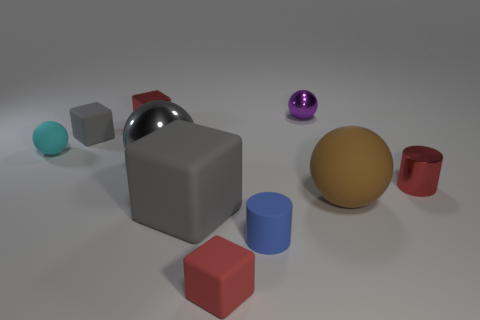There is a gray block on the left side of the gray thing that is in front of the brown matte ball; are there any large gray metallic balls right of it?
Keep it short and to the point. Yes. What material is the gray sphere that is in front of the shiny cube?
Provide a short and direct response. Metal. There is a tiny gray object; is it the same shape as the small purple metallic thing to the left of the tiny metallic cylinder?
Your response must be concise. No. Are there an equal number of red matte blocks that are behind the large gray rubber cube and large gray objects behind the purple metallic thing?
Make the answer very short. Yes. How many other things are made of the same material as the tiny cyan sphere?
Provide a short and direct response. 5. How many shiny things are purple things or gray balls?
Make the answer very short. 2. There is a shiny object to the right of the big brown matte sphere; is its shape the same as the blue object?
Offer a very short reply. Yes. Are there more matte cubes behind the small blue object than tiny purple metal balls?
Give a very brief answer. Yes. How many things are both on the right side of the small purple shiny ball and in front of the tiny red metallic cylinder?
Give a very brief answer. 1. What color is the tiny sphere that is right of the gray rubber thing left of the red metal block?
Give a very brief answer. Purple. 